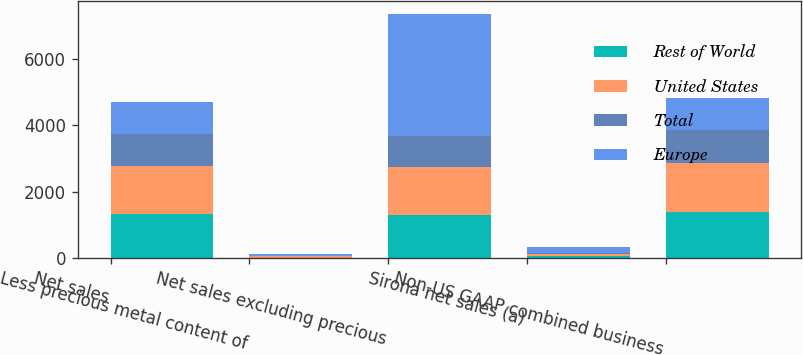<chart> <loc_0><loc_0><loc_500><loc_500><stacked_bar_chart><ecel><fcel>Net sales<fcel>Less precious metal content of<fcel>Net sales excluding precious<fcel>Sirona net sales (a)<fcel>Non-US GAAP combined business<nl><fcel>Rest of World<fcel>1311.6<fcel>5.2<fcel>1306.4<fcel>60.5<fcel>1378.7<nl><fcel>United States<fcel>1463.2<fcel>41.5<fcel>1421.7<fcel>59.4<fcel>1482.3<nl><fcel>Total<fcel>970.5<fcel>17.6<fcel>952.9<fcel>40.8<fcel>993.7<nl><fcel>Europe<fcel>961.7<fcel>64.3<fcel>3681<fcel>160.7<fcel>961.7<nl></chart> 